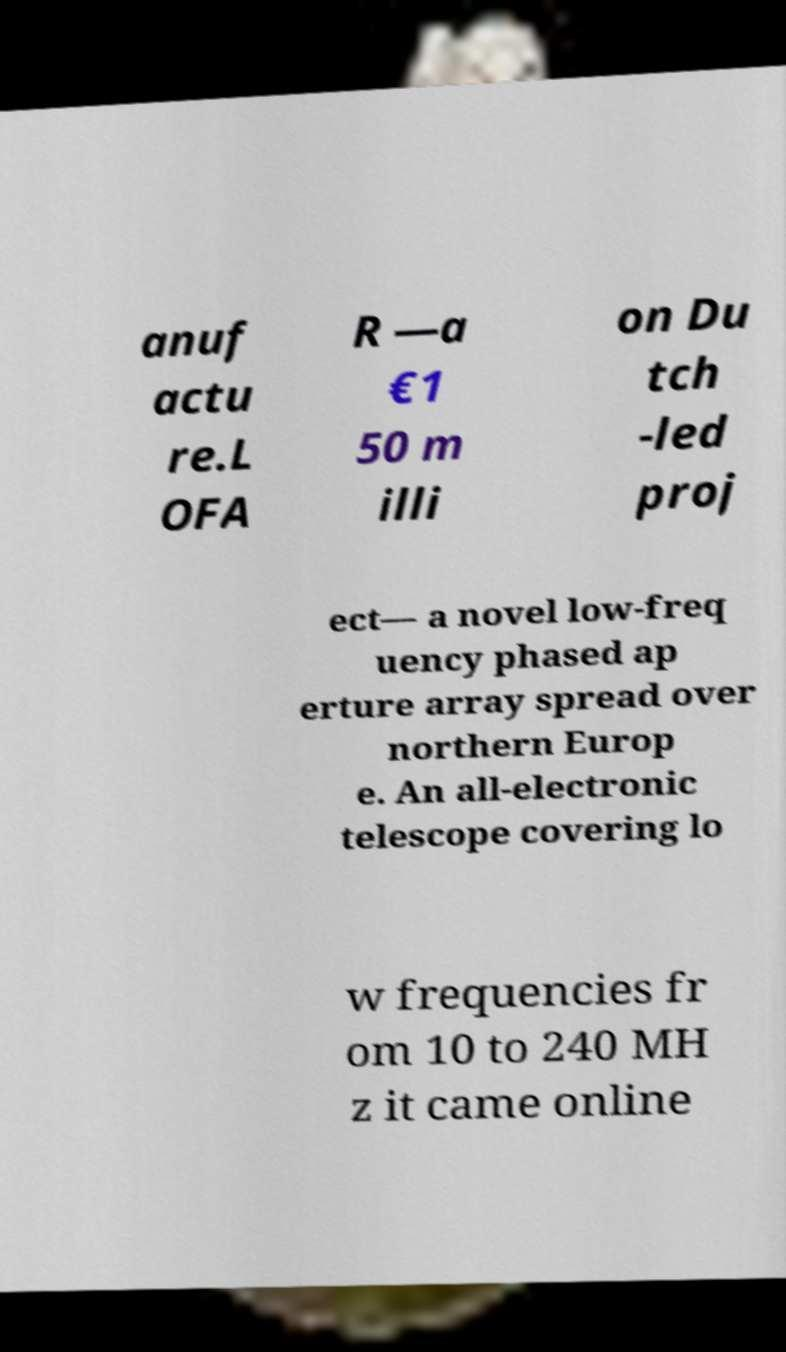What messages or text are displayed in this image? I need them in a readable, typed format. anuf actu re.L OFA R —a €1 50 m illi on Du tch -led proj ect— a novel low-freq uency phased ap erture array spread over northern Europ e. An all-electronic telescope covering lo w frequencies fr om 10 to 240 MH z it came online 